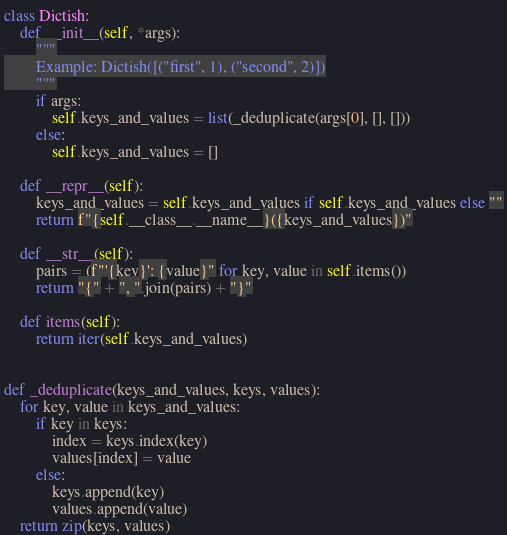<code> <loc_0><loc_0><loc_500><loc_500><_Python_>class Dictish:
    def __init__(self, *args):
        """
        Example: Dictish([("first", 1), ("second", 2)])
        """
        if args:
            self.keys_and_values = list(_deduplicate(args[0], [], []))
        else:
            self.keys_and_values = []

    def __repr__(self):
        keys_and_values = self.keys_and_values if self.keys_and_values else ""
        return f"{self.__class__.__name__}({keys_and_values})"

    def __str__(self):
        pairs = (f"'{key}': {value}" for key, value in self.items())
        return "{" + ", ".join(pairs) + "}"

    def items(self):
        return iter(self.keys_and_values)


def _deduplicate(keys_and_values, keys, values):
    for key, value in keys_and_values:
        if key in keys:
            index = keys.index(key)
            values[index] = value
        else:
            keys.append(key)
            values.append(value)
    return zip(keys, values)
</code> 